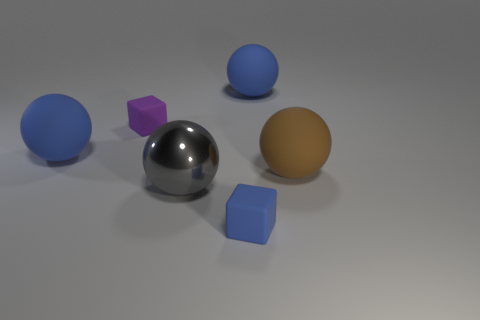Subtract all gray cubes. How many blue balls are left? 2 Subtract all brown matte spheres. How many spheres are left? 3 Add 1 blue objects. How many objects exist? 7 Subtract 2 spheres. How many spheres are left? 2 Subtract all gray spheres. How many spheres are left? 3 Subtract all yellow spheres. Subtract all cyan cubes. How many spheres are left? 4 Subtract all spheres. How many objects are left? 2 Add 5 metallic balls. How many metallic balls exist? 6 Subtract 0 purple cylinders. How many objects are left? 6 Subtract all large gray objects. Subtract all cubes. How many objects are left? 3 